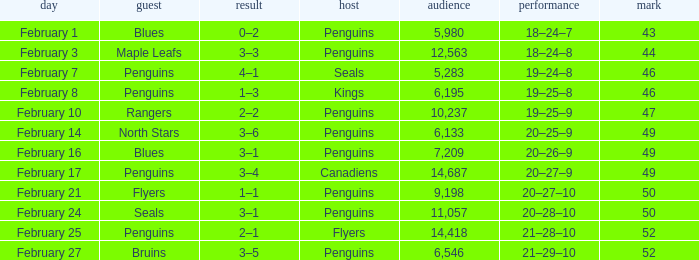Record of 21–29–10 had what total number of points? 1.0. 